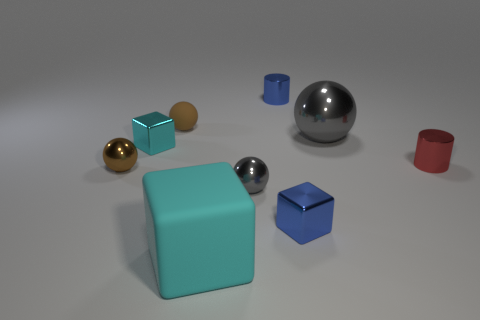Subtract all brown balls. How many were subtracted if there are1brown balls left? 1 Add 1 big red matte cylinders. How many objects exist? 10 Subtract all cubes. How many objects are left? 6 Subtract 1 cyan cubes. How many objects are left? 8 Subtract all green cylinders. Subtract all blue cylinders. How many objects are left? 8 Add 7 big gray metallic spheres. How many big gray metallic spheres are left? 8 Add 3 small blue blocks. How many small blue blocks exist? 4 